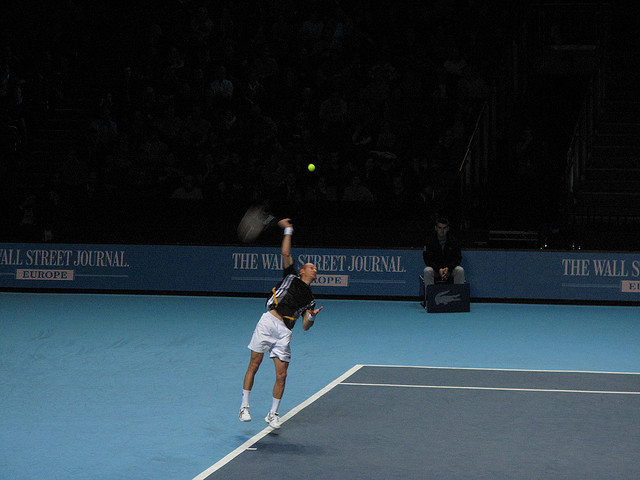Read all the text in this image. ALL STREET JOURNAL EUROPE THE F S WALL THE OPE JOURNAL STREET WALL 